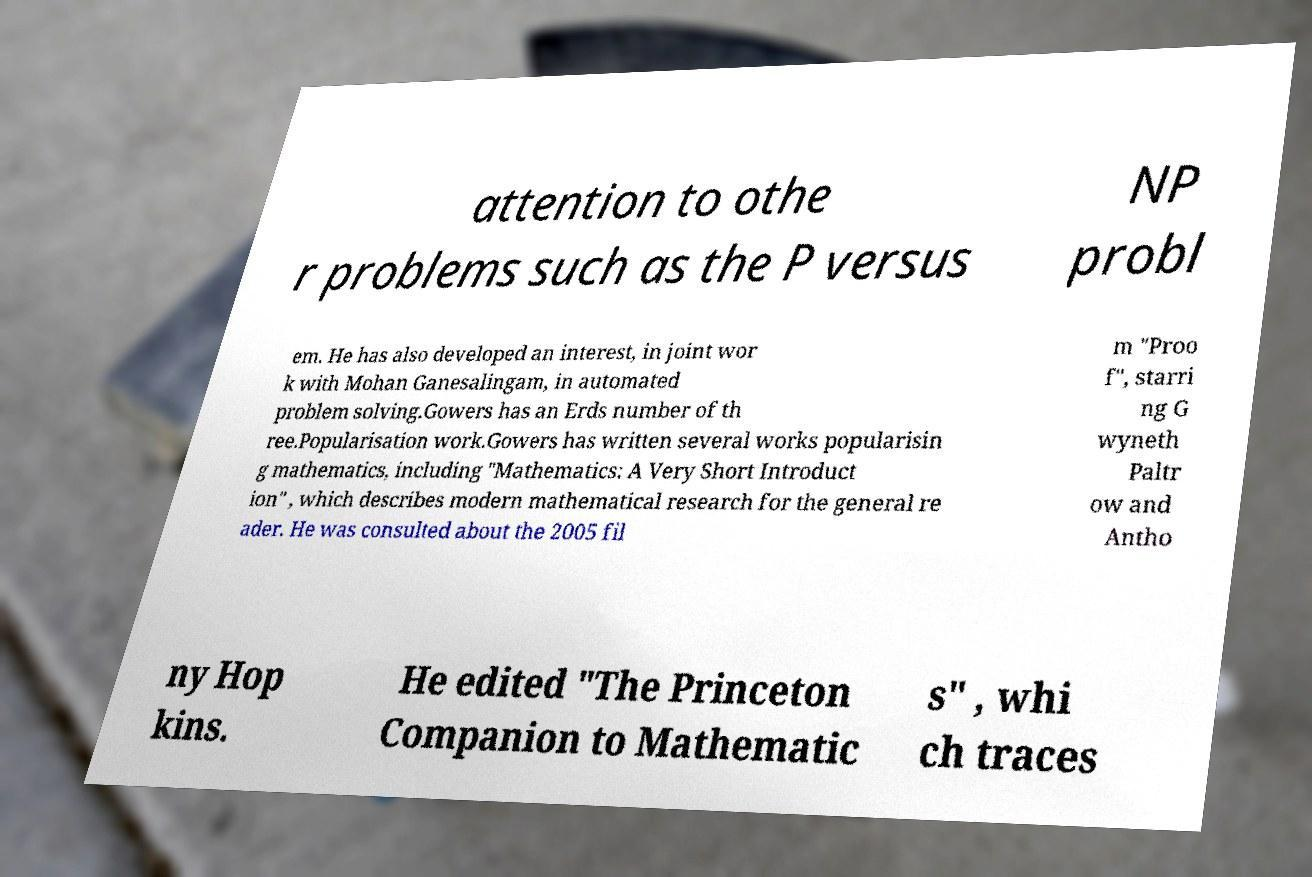There's text embedded in this image that I need extracted. Can you transcribe it verbatim? attention to othe r problems such as the P versus NP probl em. He has also developed an interest, in joint wor k with Mohan Ganesalingam, in automated problem solving.Gowers has an Erds number of th ree.Popularisation work.Gowers has written several works popularisin g mathematics, including "Mathematics: A Very Short Introduct ion" , which describes modern mathematical research for the general re ader. He was consulted about the 2005 fil m "Proo f", starri ng G wyneth Paltr ow and Antho ny Hop kins. He edited "The Princeton Companion to Mathematic s" , whi ch traces 